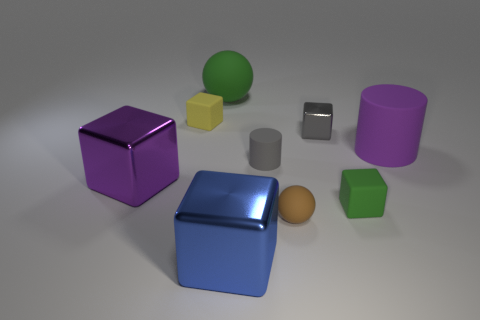What number of other things are made of the same material as the large purple cylinder?
Your answer should be compact. 5. Are there any other large things of the same shape as the gray rubber thing?
Your answer should be compact. Yes. What number of objects are big matte cylinders or objects that are to the left of the blue cube?
Your response must be concise. 4. What color is the rubber block in front of the large purple matte object?
Your response must be concise. Green. There is a green rubber object that is on the right side of the small rubber sphere; does it have the same size as the green rubber thing to the left of the tiny gray block?
Make the answer very short. No. Is there a green ball that has the same size as the yellow thing?
Your answer should be very brief. No. How many large objects are on the right side of the big purple thing to the left of the tiny yellow rubber thing?
Offer a terse response. 3. What is the material of the small gray cylinder?
Ensure brevity in your answer.  Rubber. There is a large green thing; how many small blocks are on the left side of it?
Provide a succinct answer. 1. Is the color of the tiny sphere the same as the large cylinder?
Offer a very short reply. No. 